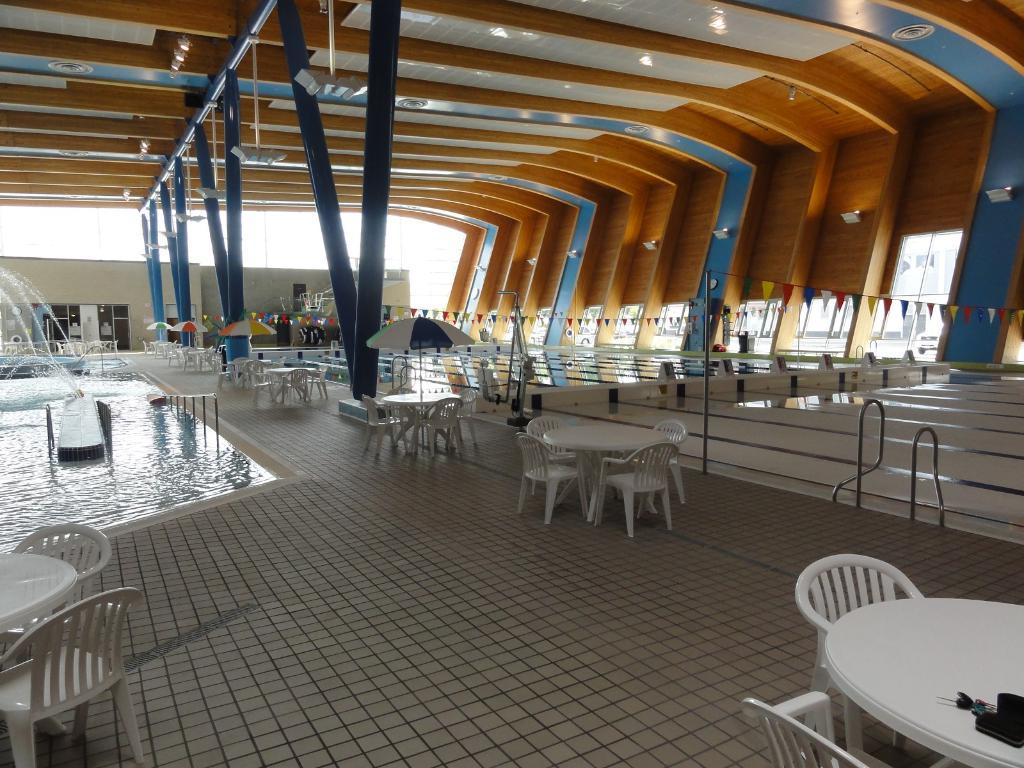What type of furniture can be seen in the image? There are chairs in the image. What color are the chairs and table? The chairs and table are white. What objects are associated with the chairs and table? There are umbrellas, poles, and flags in the image. What type of recreational area is visible in the image? There is a pool in the image. What additional structure can be seen in the image? There is a brown and blue shed in the image. What type of noise can be heard coming from the crib in the image? There is no crib present in the image, so it's not possible to determine what noise might be heard. 